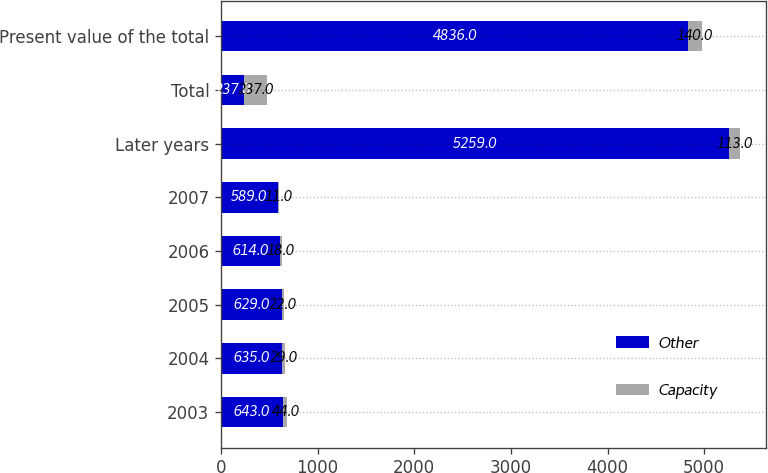<chart> <loc_0><loc_0><loc_500><loc_500><stacked_bar_chart><ecel><fcel>2003<fcel>2004<fcel>2005<fcel>2006<fcel>2007<fcel>Later years<fcel>Total<fcel>Present value of the total<nl><fcel>Other<fcel>643<fcel>635<fcel>629<fcel>614<fcel>589<fcel>5259<fcel>237<fcel>4836<nl><fcel>Capacity<fcel>44<fcel>29<fcel>22<fcel>18<fcel>11<fcel>113<fcel>237<fcel>140<nl></chart> 